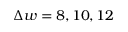<formula> <loc_0><loc_0><loc_500><loc_500>\Delta w = 8 , 1 0 , 1 2</formula> 